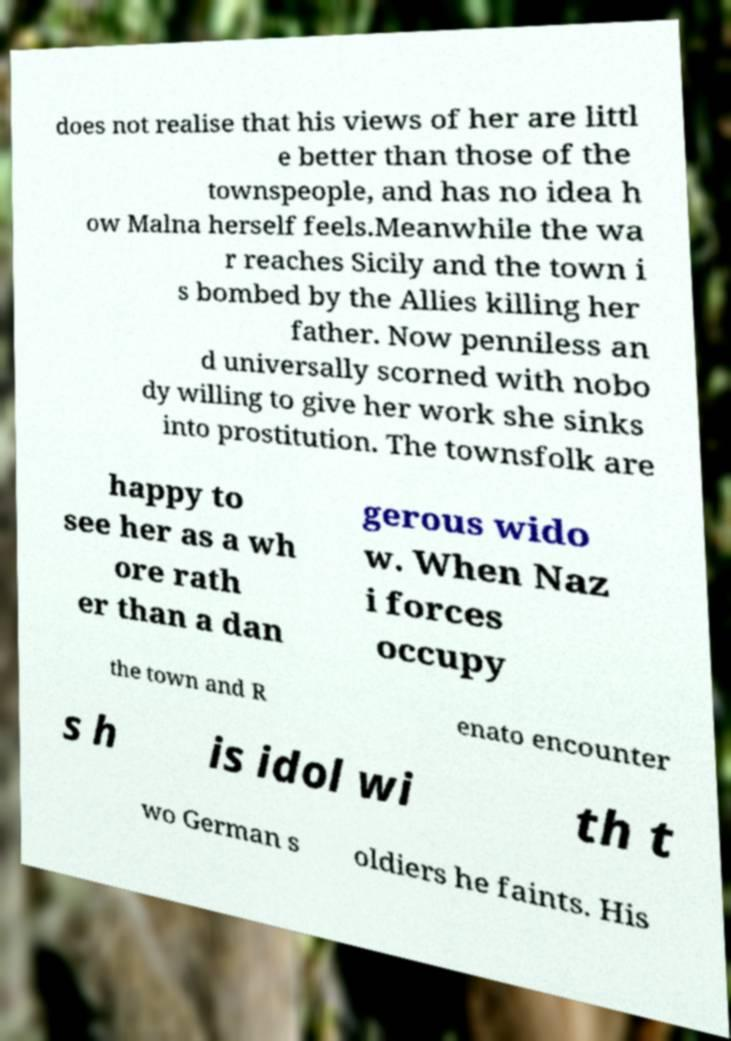Please read and relay the text visible in this image. What does it say? does not realise that his views of her are littl e better than those of the townspeople, and has no idea h ow Malna herself feels.Meanwhile the wa r reaches Sicily and the town i s bombed by the Allies killing her father. Now penniless an d universally scorned with nobo dy willing to give her work she sinks into prostitution. The townsfolk are happy to see her as a wh ore rath er than a dan gerous wido w. When Naz i forces occupy the town and R enato encounter s h is idol wi th t wo German s oldiers he faints. His 